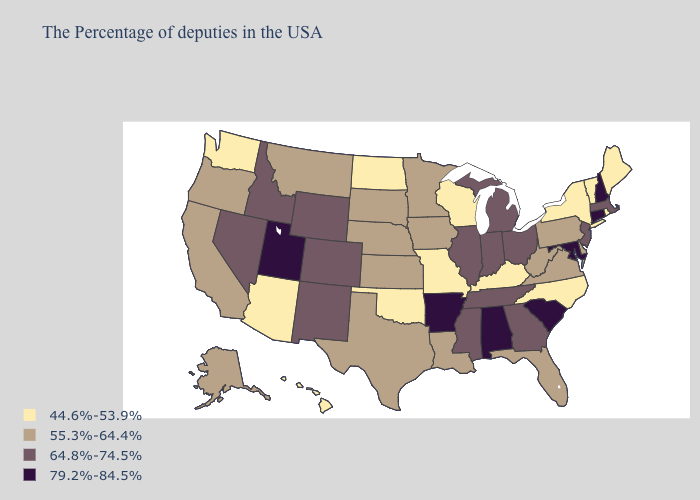What is the highest value in states that border Massachusetts?
Keep it brief. 79.2%-84.5%. What is the highest value in the Northeast ?
Keep it brief. 79.2%-84.5%. Among the states that border New Hampshire , does Massachusetts have the lowest value?
Concise answer only. No. Which states have the lowest value in the Northeast?
Quick response, please. Maine, Rhode Island, Vermont, New York. What is the value of Delaware?
Be succinct. 55.3%-64.4%. What is the value of Nebraska?
Give a very brief answer. 55.3%-64.4%. Name the states that have a value in the range 55.3%-64.4%?
Keep it brief. Delaware, Pennsylvania, Virginia, West Virginia, Florida, Louisiana, Minnesota, Iowa, Kansas, Nebraska, Texas, South Dakota, Montana, California, Oregon, Alaska. What is the value of Rhode Island?
Short answer required. 44.6%-53.9%. What is the value of New York?
Answer briefly. 44.6%-53.9%. Does Texas have the same value as West Virginia?
Short answer required. Yes. What is the value of Oklahoma?
Write a very short answer. 44.6%-53.9%. Which states have the highest value in the USA?
Short answer required. New Hampshire, Connecticut, Maryland, South Carolina, Alabama, Arkansas, Utah. Does the first symbol in the legend represent the smallest category?
Concise answer only. Yes. Name the states that have a value in the range 79.2%-84.5%?
Short answer required. New Hampshire, Connecticut, Maryland, South Carolina, Alabama, Arkansas, Utah. Does Illinois have the lowest value in the MidWest?
Give a very brief answer. No. 